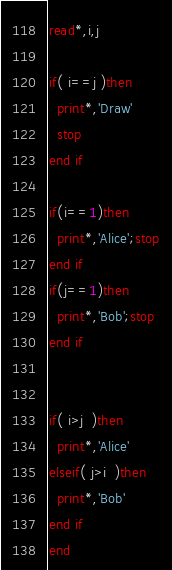Convert code to text. <code><loc_0><loc_0><loc_500><loc_500><_FORTRAN_>read*,i,j

if( i==j )then
  print*,'Draw'
  stop
end if

if(i==1)then
  print*,'Alice';stop
end if
if(j==1)then
  print*,'Bob';stop
end if


if( i>j  )then
  print*,'Alice'
elseif( j>i  )then
  print*,'Bob'
end if
end
</code> 